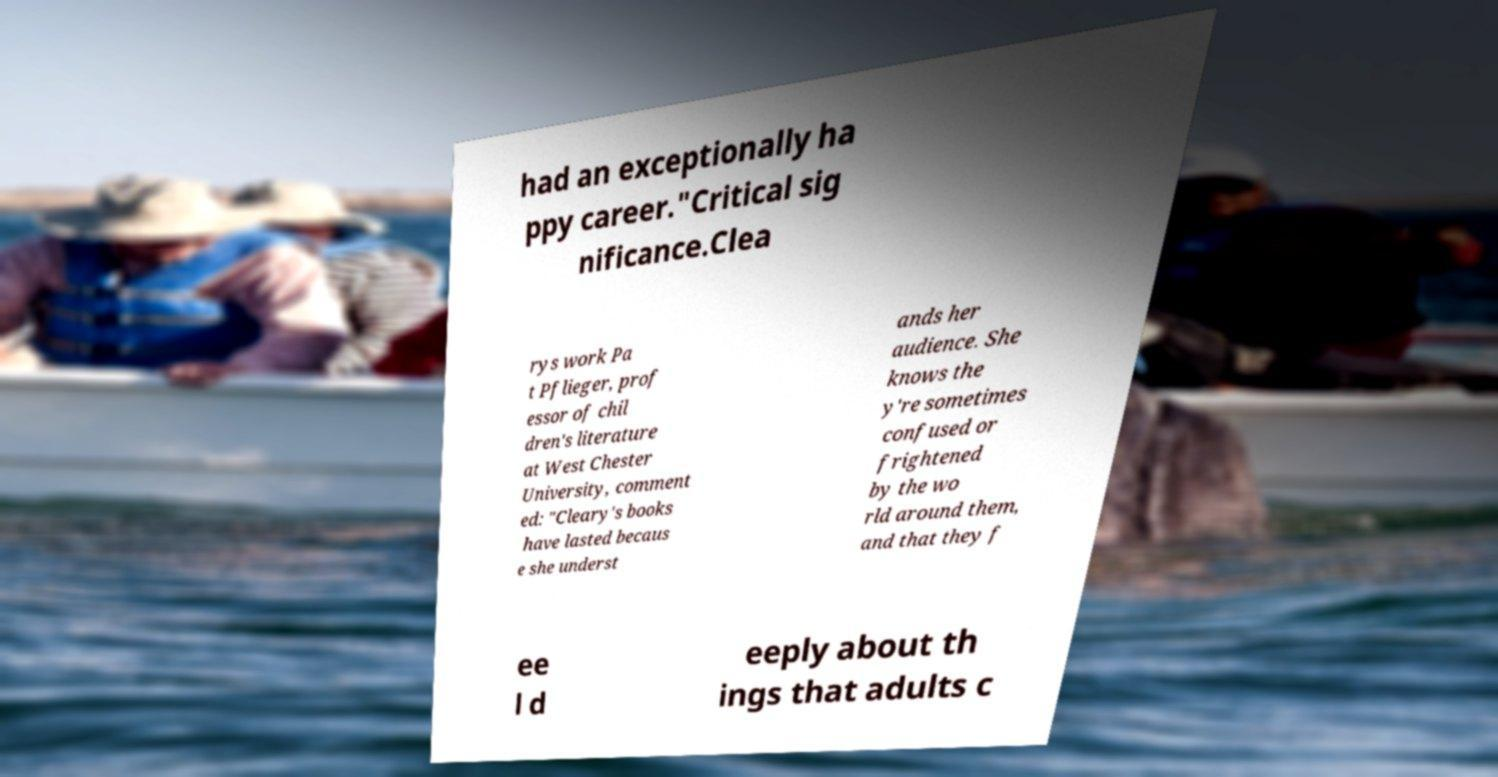Could you assist in decoding the text presented in this image and type it out clearly? had an exceptionally ha ppy career."Critical sig nificance.Clea rys work Pa t Pflieger, prof essor of chil dren's literature at West Chester University, comment ed: "Cleary's books have lasted becaus e she underst ands her audience. She knows the y're sometimes confused or frightened by the wo rld around them, and that they f ee l d eeply about th ings that adults c 